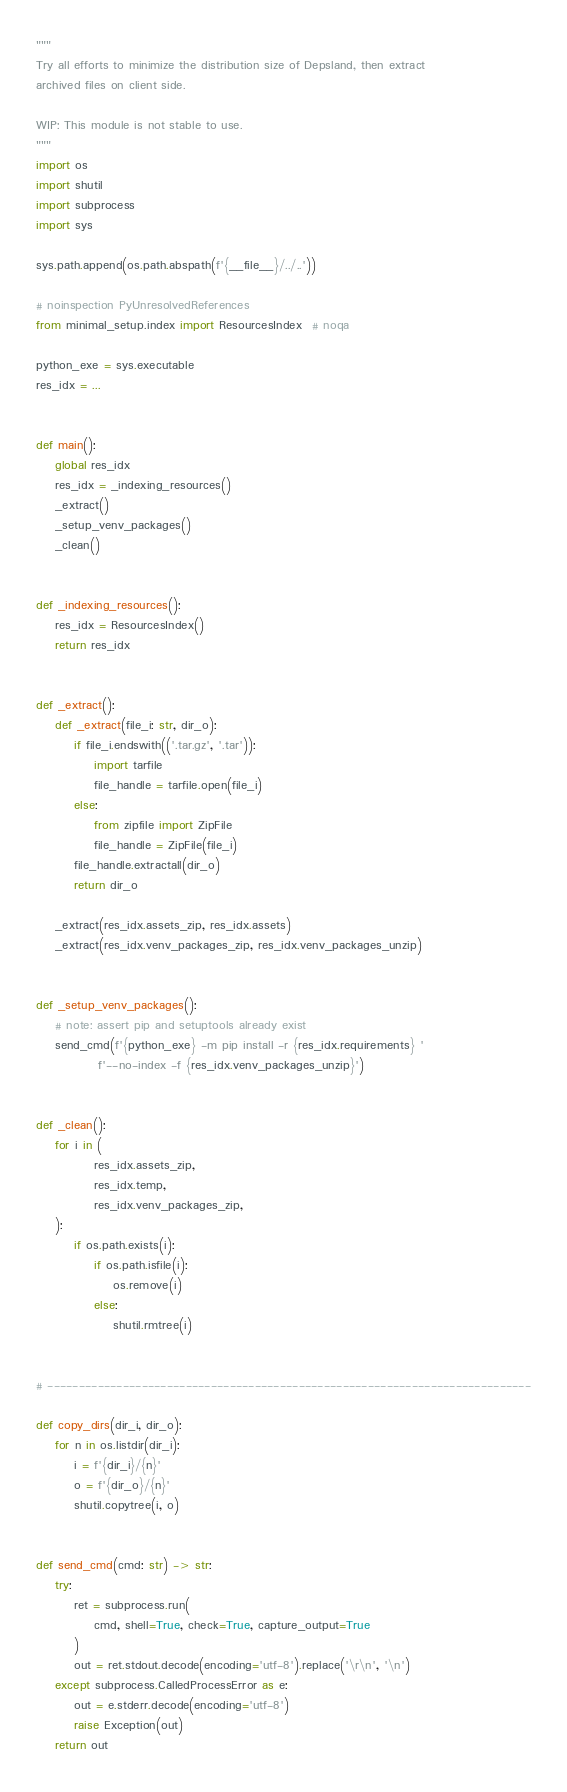Convert code to text. <code><loc_0><loc_0><loc_500><loc_500><_Python_>"""
Try all efforts to minimize the distribution size of Depsland, then extract
archived files on client side.

WIP: This module is not stable to use.
"""
import os
import shutil
import subprocess
import sys

sys.path.append(os.path.abspath(f'{__file__}/../..'))

# noinspection PyUnresolvedReferences
from minimal_setup.index import ResourcesIndex  # noqa

python_exe = sys.executable
res_idx = ...


def main():
    global res_idx
    res_idx = _indexing_resources()
    _extract()
    _setup_venv_packages()
    _clean()


def _indexing_resources():
    res_idx = ResourcesIndex()
    return res_idx


def _extract():
    def _extract(file_i: str, dir_o):
        if file_i.endswith(('.tar.gz', '.tar')):
            import tarfile
            file_handle = tarfile.open(file_i)
        else:
            from zipfile import ZipFile
            file_handle = ZipFile(file_i)
        file_handle.extractall(dir_o)
        return dir_o
    
    _extract(res_idx.assets_zip, res_idx.assets)
    _extract(res_idx.venv_packages_zip, res_idx.venv_packages_unzip)


def _setup_venv_packages():
    # note: assert pip and setuptools already exist
    send_cmd(f'{python_exe} -m pip install -r {res_idx.requirements} '
             f'--no-index -f {res_idx.venv_packages_unzip}')


def _clean():
    for i in (
            res_idx.assets_zip,
            res_idx.temp,
            res_idx.venv_packages_zip,
    ):
        if os.path.exists(i):
            if os.path.isfile(i):
                os.remove(i)
            else:
                shutil.rmtree(i)


# -----------------------------------------------------------------------------

def copy_dirs(dir_i, dir_o):
    for n in os.listdir(dir_i):
        i = f'{dir_i}/{n}'
        o = f'{dir_o}/{n}'
        shutil.copytree(i, o)


def send_cmd(cmd: str) -> str:
    try:
        ret = subprocess.run(
            cmd, shell=True, check=True, capture_output=True
        )
        out = ret.stdout.decode(encoding='utf-8').replace('\r\n', '\n')
    except subprocess.CalledProcessError as e:
        out = e.stderr.decode(encoding='utf-8')
        raise Exception(out)
    return out
</code> 